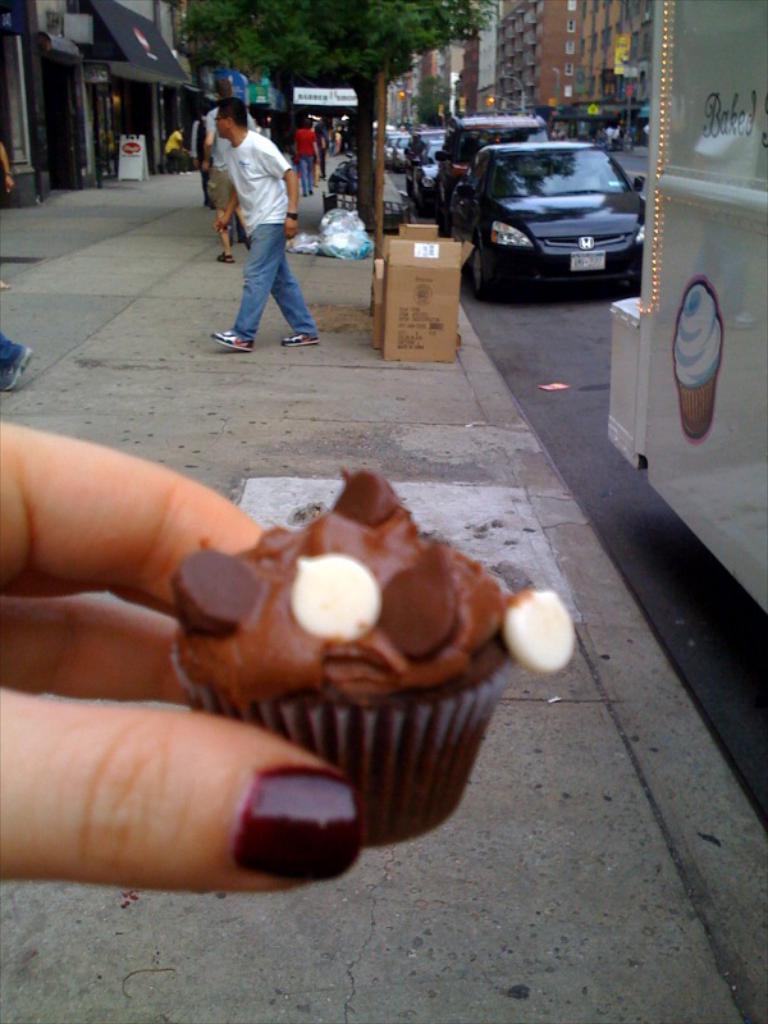Describe this image in one or two sentences. In this image, on the left side, we can see person hand holding a cupcake. On the right side, we can see a white color vehicle. On the left side, we can also see the leg of a person, we can also see the hand of a person, hoardings, building. In the middle of the image, we can also see a person walking on the footpath. In the background, we can also see some boxes, vehicles which are placed on the road, buildings, trees, footpath, a group of people walking on the footpath. At the bottom, we can see a road and a footpath. 